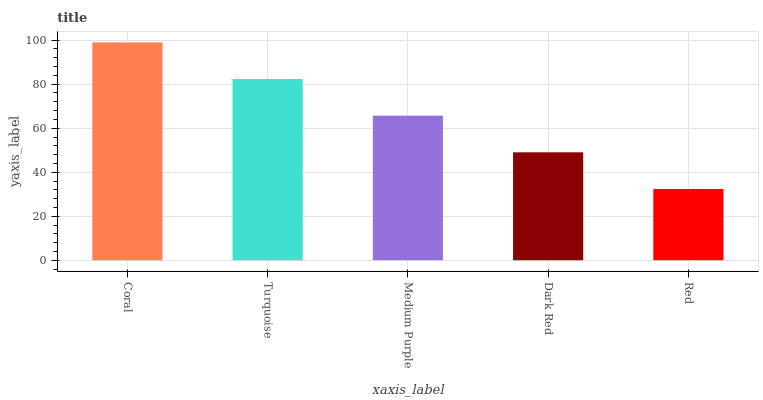Is Coral the maximum?
Answer yes or no. Yes. Is Turquoise the minimum?
Answer yes or no. No. Is Turquoise the maximum?
Answer yes or no. No. Is Coral greater than Turquoise?
Answer yes or no. Yes. Is Turquoise less than Coral?
Answer yes or no. Yes. Is Turquoise greater than Coral?
Answer yes or no. No. Is Coral less than Turquoise?
Answer yes or no. No. Is Medium Purple the high median?
Answer yes or no. Yes. Is Medium Purple the low median?
Answer yes or no. Yes. Is Coral the high median?
Answer yes or no. No. Is Coral the low median?
Answer yes or no. No. 